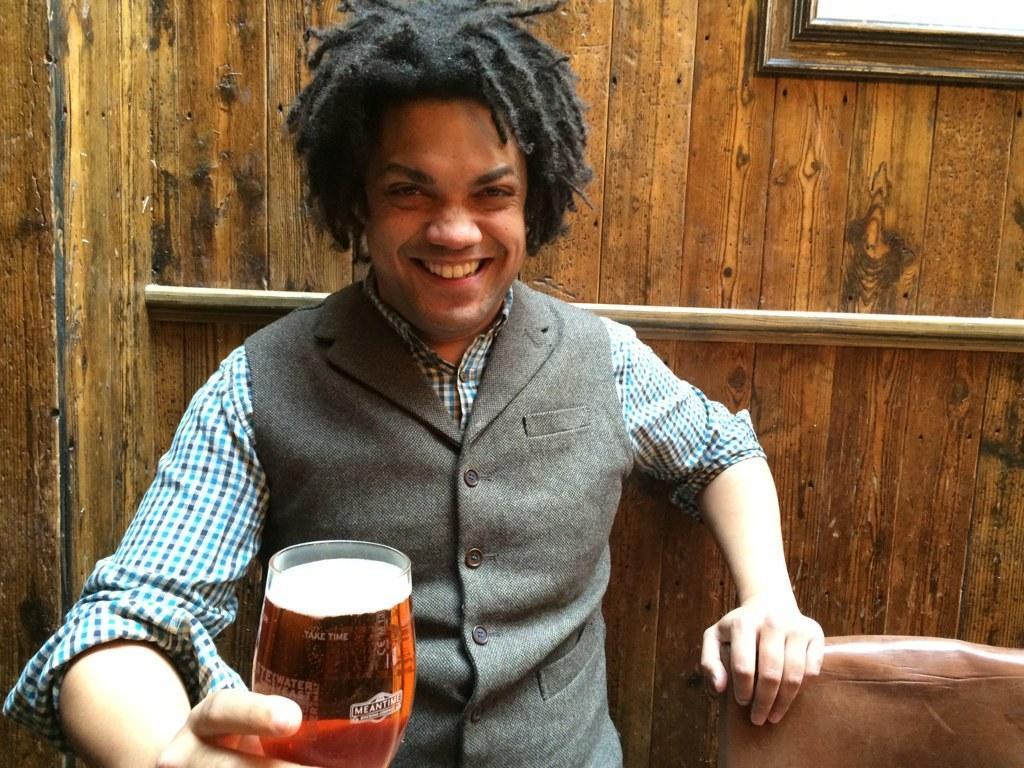Describe this image in one or two sentences. This image consists of man wearing a vase coat smiling and holding a beer glass and back side of him its wooden wall, 